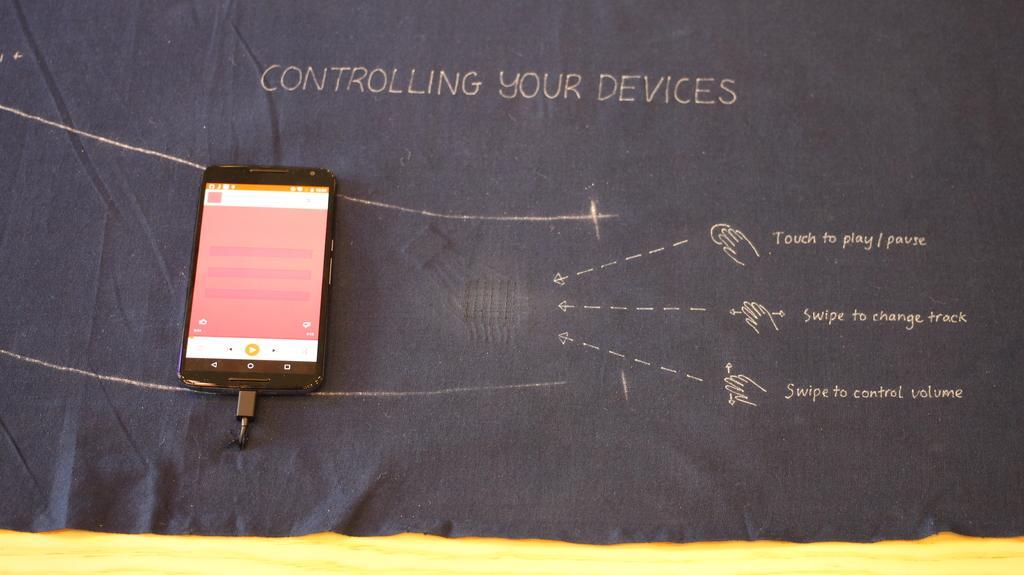<image>
Offer a succinct explanation of the picture presented. A cloth that says "controlling your devices" had a tablet sitting on top of it. 